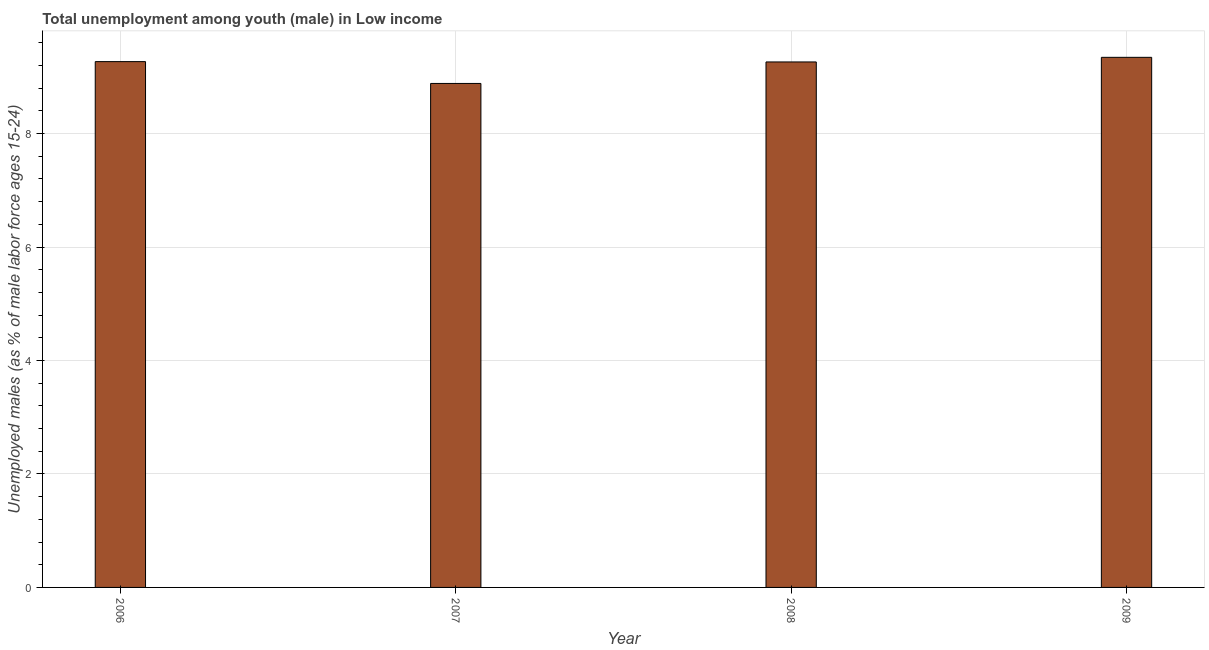Does the graph contain any zero values?
Give a very brief answer. No. Does the graph contain grids?
Your response must be concise. Yes. What is the title of the graph?
Your answer should be compact. Total unemployment among youth (male) in Low income. What is the label or title of the X-axis?
Offer a very short reply. Year. What is the label or title of the Y-axis?
Give a very brief answer. Unemployed males (as % of male labor force ages 15-24). What is the unemployed male youth population in 2006?
Your answer should be very brief. 9.27. Across all years, what is the maximum unemployed male youth population?
Offer a terse response. 9.34. Across all years, what is the minimum unemployed male youth population?
Provide a short and direct response. 8.88. In which year was the unemployed male youth population minimum?
Keep it short and to the point. 2007. What is the sum of the unemployed male youth population?
Make the answer very short. 36.76. What is the difference between the unemployed male youth population in 2006 and 2008?
Your response must be concise. 0.01. What is the average unemployed male youth population per year?
Make the answer very short. 9.19. What is the median unemployed male youth population?
Ensure brevity in your answer.  9.27. What is the difference between the highest and the second highest unemployed male youth population?
Your answer should be very brief. 0.08. What is the difference between the highest and the lowest unemployed male youth population?
Offer a very short reply. 0.46. How many years are there in the graph?
Offer a terse response. 4. What is the difference between two consecutive major ticks on the Y-axis?
Make the answer very short. 2. What is the Unemployed males (as % of male labor force ages 15-24) in 2006?
Provide a short and direct response. 9.27. What is the Unemployed males (as % of male labor force ages 15-24) in 2007?
Your answer should be compact. 8.88. What is the Unemployed males (as % of male labor force ages 15-24) of 2008?
Your response must be concise. 9.26. What is the Unemployed males (as % of male labor force ages 15-24) in 2009?
Provide a succinct answer. 9.34. What is the difference between the Unemployed males (as % of male labor force ages 15-24) in 2006 and 2007?
Your answer should be very brief. 0.38. What is the difference between the Unemployed males (as % of male labor force ages 15-24) in 2006 and 2008?
Your answer should be very brief. 0.01. What is the difference between the Unemployed males (as % of male labor force ages 15-24) in 2006 and 2009?
Provide a succinct answer. -0.08. What is the difference between the Unemployed males (as % of male labor force ages 15-24) in 2007 and 2008?
Your response must be concise. -0.38. What is the difference between the Unemployed males (as % of male labor force ages 15-24) in 2007 and 2009?
Give a very brief answer. -0.46. What is the difference between the Unemployed males (as % of male labor force ages 15-24) in 2008 and 2009?
Offer a very short reply. -0.08. What is the ratio of the Unemployed males (as % of male labor force ages 15-24) in 2006 to that in 2007?
Keep it short and to the point. 1.04. What is the ratio of the Unemployed males (as % of male labor force ages 15-24) in 2006 to that in 2008?
Your response must be concise. 1. What is the ratio of the Unemployed males (as % of male labor force ages 15-24) in 2007 to that in 2008?
Your response must be concise. 0.96. What is the ratio of the Unemployed males (as % of male labor force ages 15-24) in 2007 to that in 2009?
Make the answer very short. 0.95. What is the ratio of the Unemployed males (as % of male labor force ages 15-24) in 2008 to that in 2009?
Keep it short and to the point. 0.99. 